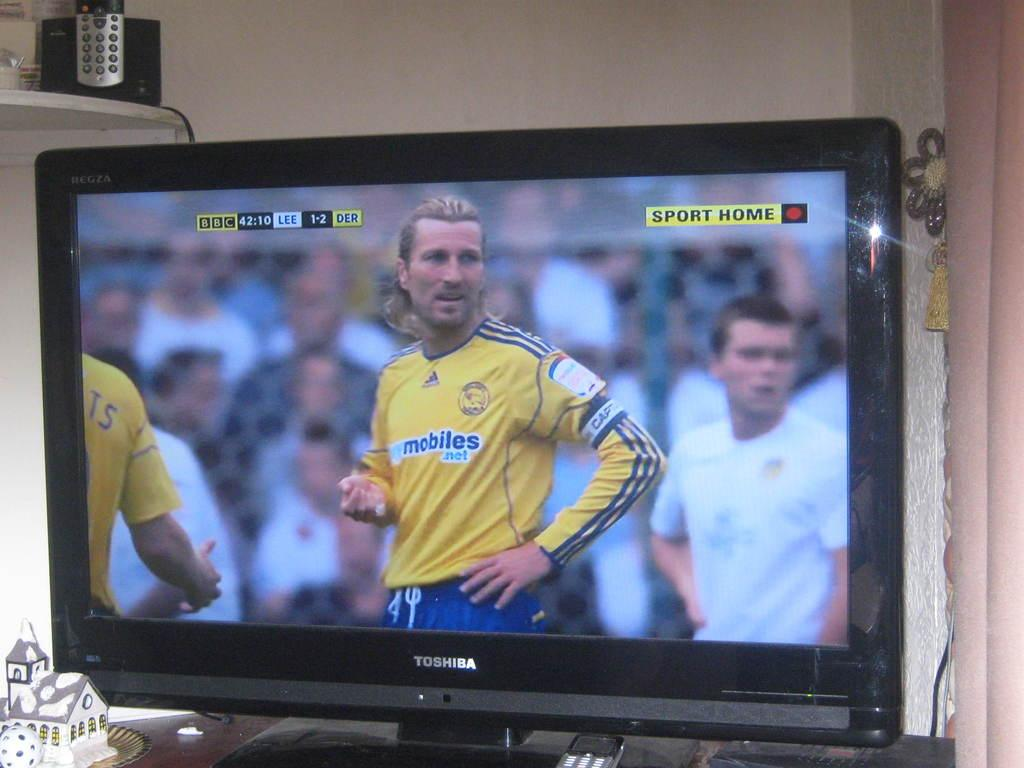Provide a one-sentence caption for the provided image. TOSHIBA TELEVISION SHOWING A SOCCER MATCH ON THE BBC CHANNEL. 